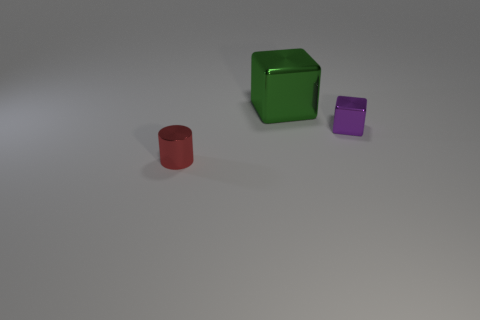Subtract 1 cylinders. How many cylinders are left? 0 Add 1 tiny gray cylinders. How many objects exist? 4 Subtract all cylinders. How many objects are left? 2 Subtract all green cubes. How many cubes are left? 1 Add 2 small red rubber cylinders. How many small red rubber cylinders exist? 2 Subtract 0 purple balls. How many objects are left? 3 Subtract all yellow cylinders. Subtract all blue spheres. How many cylinders are left? 1 Subtract all brown shiny blocks. Subtract all green metallic objects. How many objects are left? 2 Add 3 small red cylinders. How many small red cylinders are left? 4 